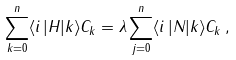Convert formula to latex. <formula><loc_0><loc_0><loc_500><loc_500>\sum _ { k = 0 } ^ { n } \langle i \, | H | k \rangle C _ { k } = \lambda \sum _ { j = 0 } ^ { n } \langle i \, | N | k \rangle C _ { k } \, ,</formula> 